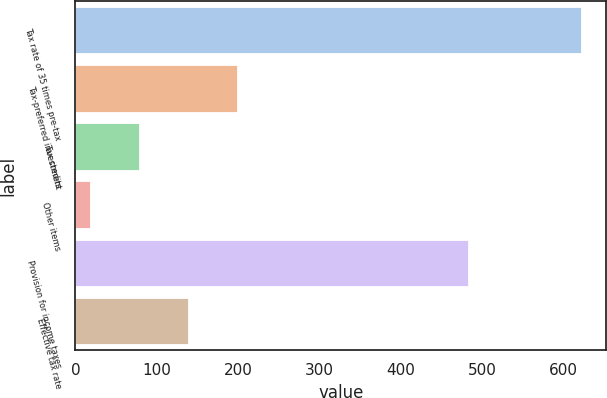<chart> <loc_0><loc_0><loc_500><loc_500><bar_chart><fcel>Tax rate of 35 times pre-tax<fcel>Tax-preferred investment<fcel>Tax credits<fcel>Other items<fcel>Provision for income taxes<fcel>Effective tax rate<nl><fcel>622<fcel>199.2<fcel>78.4<fcel>18<fcel>483<fcel>138.8<nl></chart> 